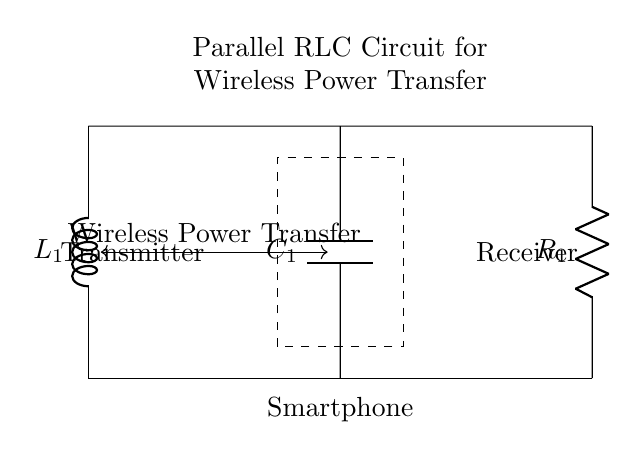What components are in this circuit? The circuit contains an inductor, a capacitor, and a resistor, which are labeled as L1, C1, and R1 respectively.
Answer: Inductor, Capacitor, Resistor What is the purpose of the dashed rectangle in the circuit? The dashed rectangle indicates the area containing the smartphone, which is the target device for wireless power transfer, showing where the circuit interfaces with the device.
Answer: Smartphone How are the components connected in the circuit? The components are connected in parallel between the transmitter and receiver along the horizontal line, meaning they share the same voltage across their terminals.
Answer: In parallel What is the main function of this RLC circuit? The primary function of the parallel RLC circuit in this context is to facilitate wireless power transfer for charging smartphones effectively by resonating at a specific frequency.
Answer: Wireless Power Transfer What does the abbreviation RLC stand for? RLC stands for Resistor, Inductor, and Capacitor, which are the three basic passive components involved in this circuit.
Answer: Resistor, Inductor, Capacitor How does the inductor influence the circuit? The inductor stores energy in a magnetic field when current flows through it, affecting the circuit's impedance and resonant frequency, contributing to efficient wireless power transfer.
Answer: Energy storage What can be inferred about the quality of wireless power transfer in this circuit? The arrangement as a parallel RLC circuit allows adjusting parameters of L1, C1, and R1 to optimize for resonance, which directly influences efficiency and effectiveness of wireless power transfer.
Answer: High efficiency 